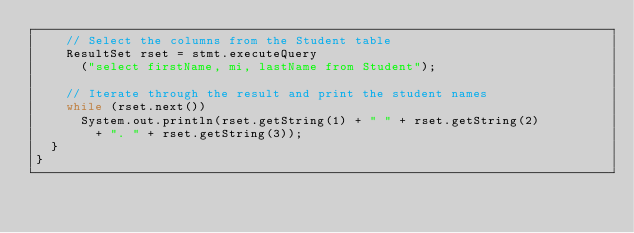<code> <loc_0><loc_0><loc_500><loc_500><_Java_>    // Select the columns from the Student table
    ResultSet rset = stmt.executeQuery
      ("select firstName, mi, lastName from Student");

    // Iterate through the result and print the student names
    while (rset.next())
      System.out.println(rset.getString(1) + " " + rset.getString(2)
        + ". " + rset.getString(3));
  }
}</code> 